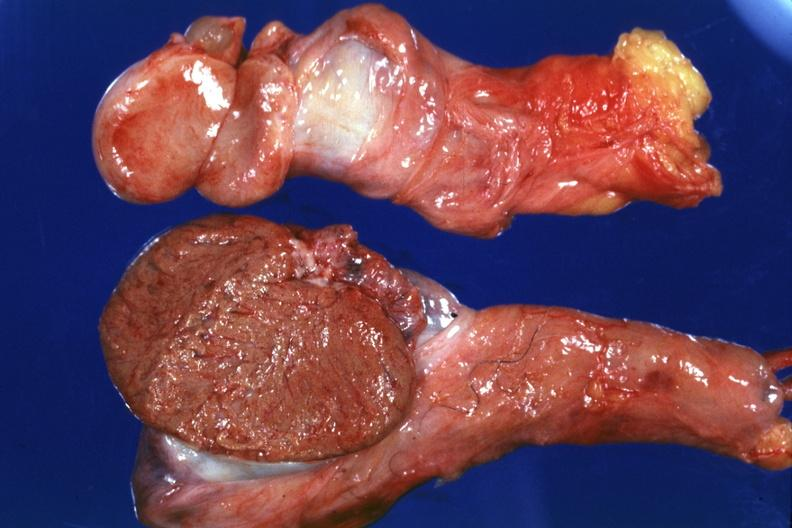how many quite small typical probably due to mumps have no history at this time?
Answer the question using a single word or phrase. One 